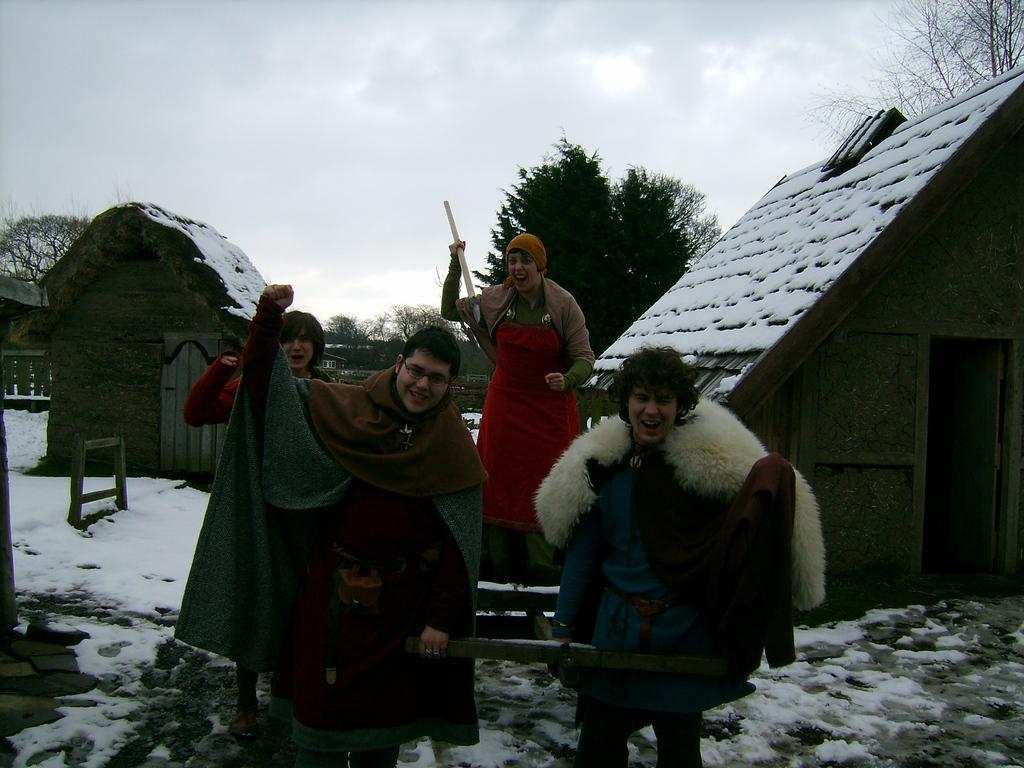Please provide a concise description of this image. This image is taken outdoors. At the top of the image there is a sky with clouds. At the bottom of the image there is a ground covered with snow. In the middle of the image there are a few people standing on the ground. In the background there are a few huts and trees. 